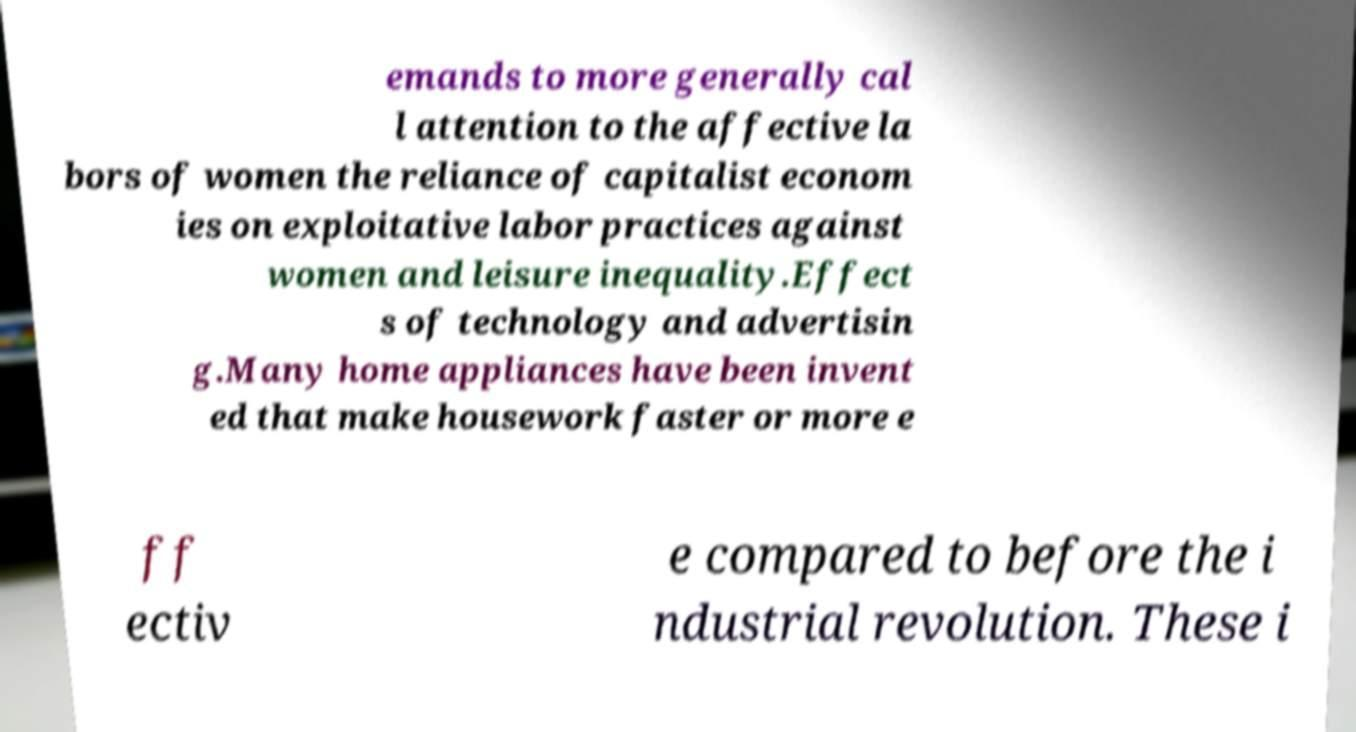There's text embedded in this image that I need extracted. Can you transcribe it verbatim? emands to more generally cal l attention to the affective la bors of women the reliance of capitalist econom ies on exploitative labor practices against women and leisure inequality.Effect s of technology and advertisin g.Many home appliances have been invent ed that make housework faster or more e ff ectiv e compared to before the i ndustrial revolution. These i 